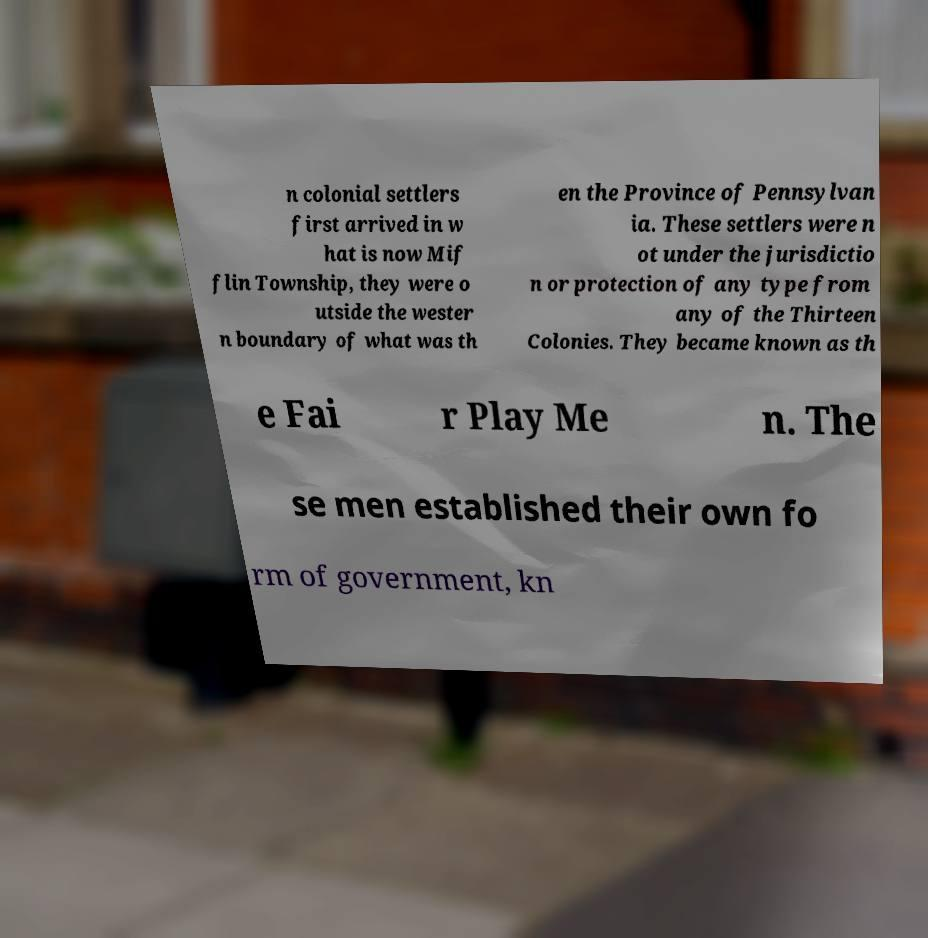Please read and relay the text visible in this image. What does it say? n colonial settlers first arrived in w hat is now Mif flin Township, they were o utside the wester n boundary of what was th en the Province of Pennsylvan ia. These settlers were n ot under the jurisdictio n or protection of any type from any of the Thirteen Colonies. They became known as th e Fai r Play Me n. The se men established their own fo rm of government, kn 